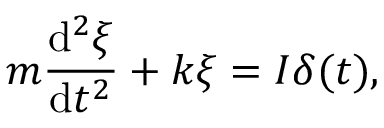Convert formula to latex. <formula><loc_0><loc_0><loc_500><loc_500>m { \frac { d ^ { 2 } \xi } { d t ^ { 2 } } } + k \xi = I \delta ( t ) ,</formula> 